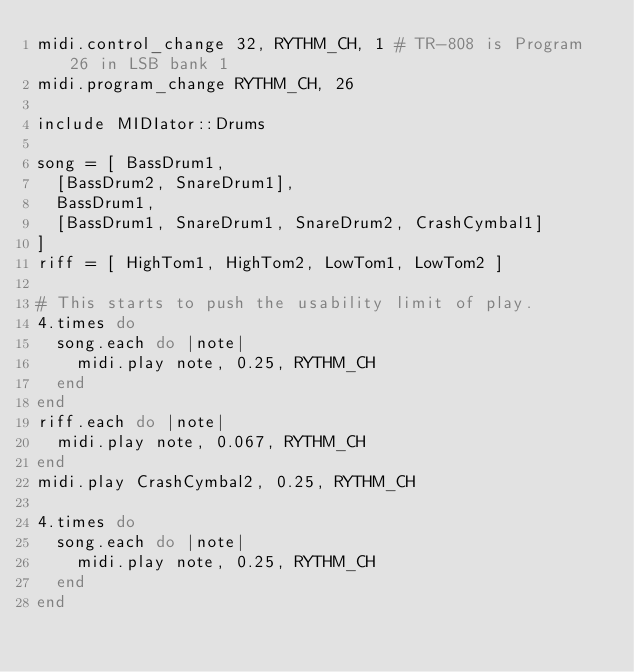Convert code to text. <code><loc_0><loc_0><loc_500><loc_500><_Ruby_>midi.control_change 32, RYTHM_CH, 1 # TR-808 is Program 26 in LSB bank 1
midi.program_change RYTHM_CH, 26
 
include MIDIator::Drums
 
song = [ BassDrum1,
  [BassDrum2, SnareDrum1],
  BassDrum1,
  [BassDrum1, SnareDrum1, SnareDrum2, CrashCymbal1]
]
riff = [ HighTom1, HighTom2, LowTom1, LowTom2 ]
 
# This starts to push the usability limit of play.
4.times do
  song.each do |note|
    midi.play note, 0.25, RYTHM_CH
  end
end
riff.each do |note|
  midi.play note, 0.067, RYTHM_CH
end
midi.play CrashCymbal2, 0.25, RYTHM_CH
 
4.times do
  song.each do |note|
    midi.play note, 0.25, RYTHM_CH
  end
end
</code> 